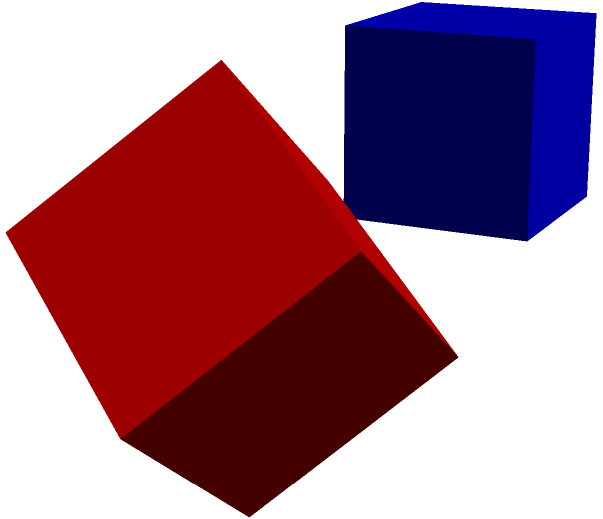In the context of 3D representations of language processing models, consider the blue cube A as a basic encoder-decoder architecture. If cube B represents the same architecture after applying specific rotations to enhance multi-lingual capabilities, which sequence of rotations transforms A into B? To solve this problem, we need to analyze the rotations applied to cube A to transform it into cube B. Let's break it down step-by-step:

1. Observe that cube B is shifted to the right of cube A.
2. Ignore the shift and focus on the rotations.
3. Compare the orientations of cubes A and B:
   a. The front face of A has become the top-right face of B.
   b. The top face of A has rotated to become the front-left face of B.
   c. The right face of A has become the bottom-right face of B.

4. To achieve this transformation, we need to apply rotations in the following order:
   a. Rotate 45° around the X-axis (aligns the front face towards the top)
   b. Rotate 30° around the Y-axis (tilts the cube slightly to the right)
   c. Rotate 60° around the Z-axis (completes the alignment of faces)

5. In the context of language processing models:
   - The X-axis rotation could represent adjusting the model's attention mechanism.
   - The Y-axis rotation might symbolize adapting the model's contextual understanding.
   - The Z-axis rotation could signify fine-tuning the output layer for different languages.

Therefore, the sequence of rotations that transforms cube A into cube B is: 45° around X, then 30° around Y, and finally 60° around Z.
Answer: 45° X, 30° Y, 60° Z 